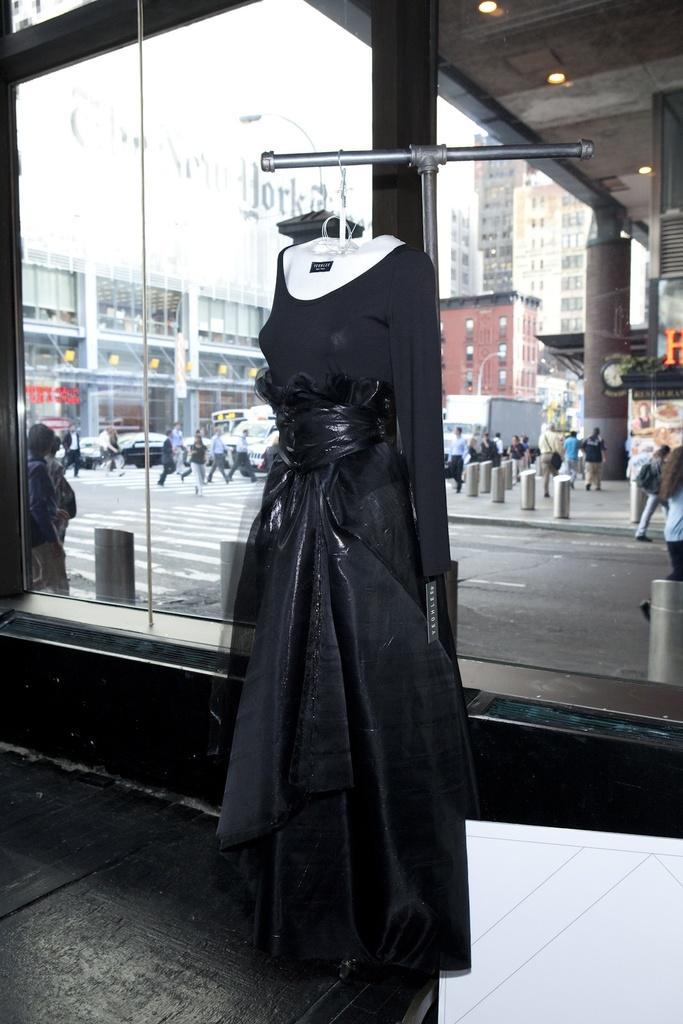How would you summarize this image in a sentence or two? In this image we can see a dress which is of b;lack color attached to the demo and in the background of the image there are some persons crossing the road, there are some vehicles and buildings. 